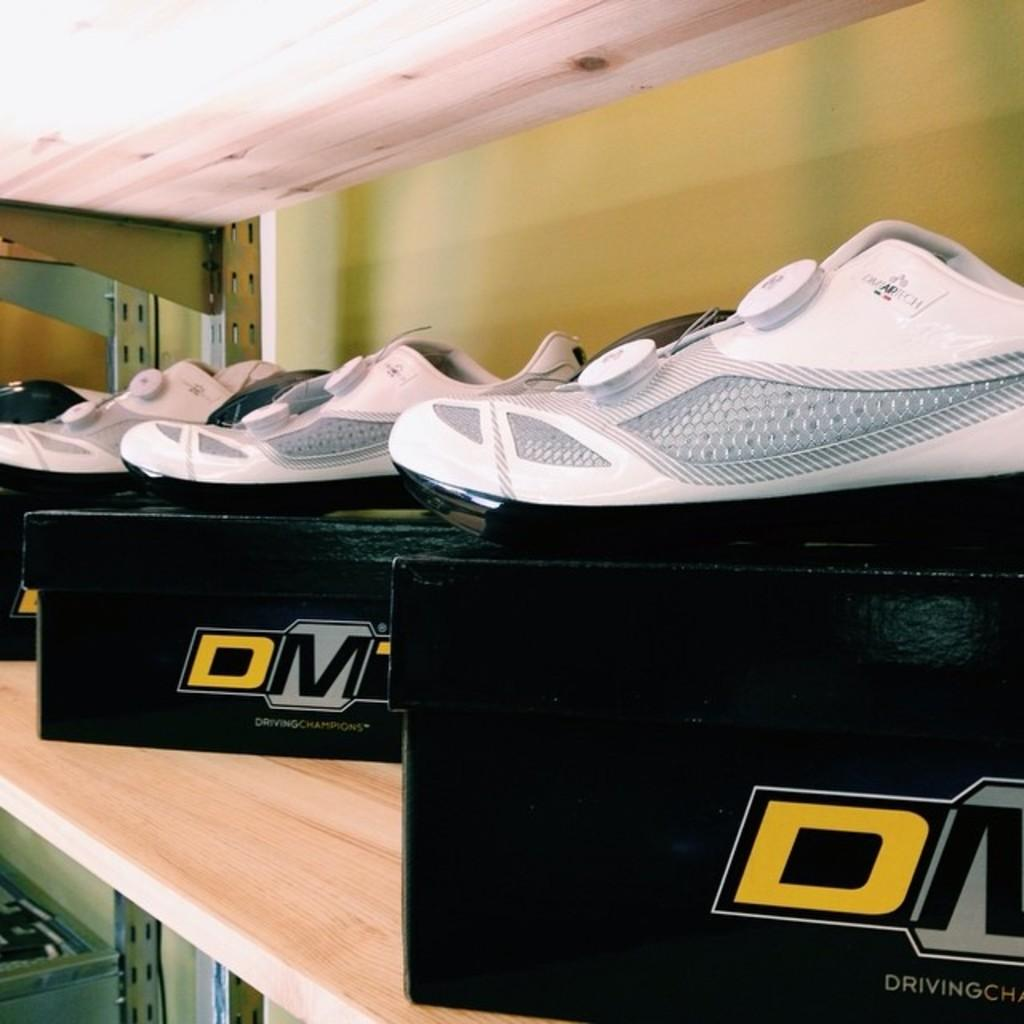What type of footwear is visible in the image? There are shoes in the image. What color are the shoes? The shoes are white in color. What is the shoes placed on in the image? The shoes are on a black object. What color is the background wall in the image? The background wall is in cream color. What type of pump is used to generate pleasure in the image? There is no pump or reference to pleasure in the image; it features shoes on a black object with a cream-colored background wall. 